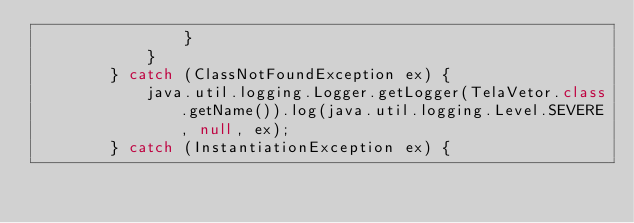Convert code to text. <code><loc_0><loc_0><loc_500><loc_500><_Java_>                }
            }
        } catch (ClassNotFoundException ex) {
            java.util.logging.Logger.getLogger(TelaVetor.class.getName()).log(java.util.logging.Level.SEVERE, null, ex);
        } catch (InstantiationException ex) {</code> 